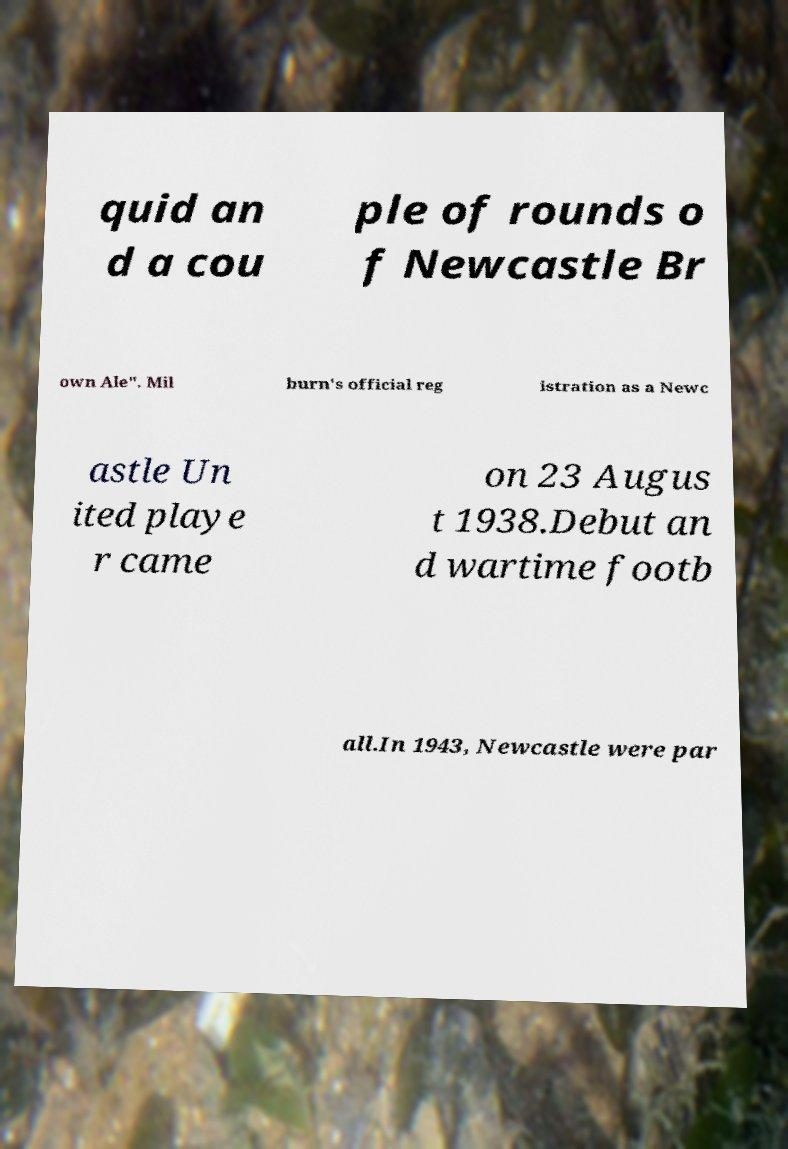There's text embedded in this image that I need extracted. Can you transcribe it verbatim? quid an d a cou ple of rounds o f Newcastle Br own Ale". Mil burn's official reg istration as a Newc astle Un ited playe r came on 23 Augus t 1938.Debut an d wartime footb all.In 1943, Newcastle were par 